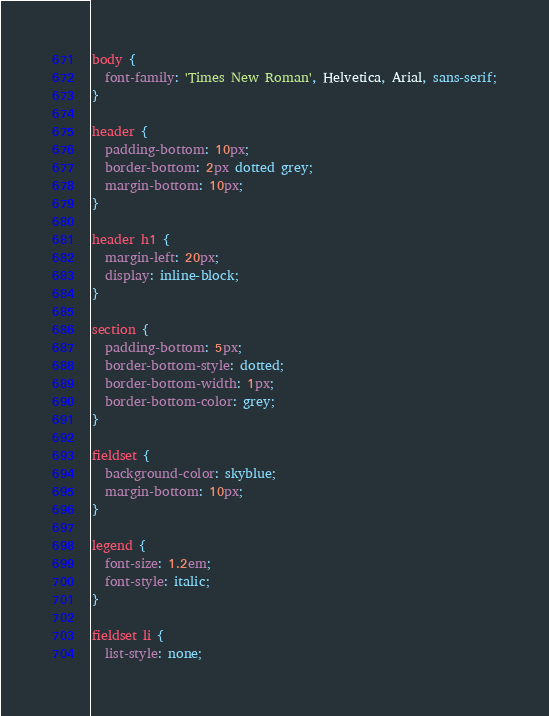<code> <loc_0><loc_0><loc_500><loc_500><_CSS_>body {
  font-family: 'Times New Roman', Helvetica, Arial, sans-serif;
}

header {
  padding-bottom: 10px;
  border-bottom: 2px dotted grey;
  margin-bottom: 10px;
}

header h1 {
  margin-left: 20px;
  display: inline-block;
}

section {
  padding-bottom: 5px;
  border-bottom-style: dotted;
  border-bottom-width: 1px;
  border-bottom-color: grey;
}

fieldset {
  background-color: skyblue;
  margin-bottom: 10px;
}

legend {
  font-size: 1.2em;
  font-style: italic;
}

fieldset li {
  list-style: none;</code> 